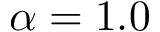<formula> <loc_0><loc_0><loc_500><loc_500>\alpha = 1 . 0</formula> 